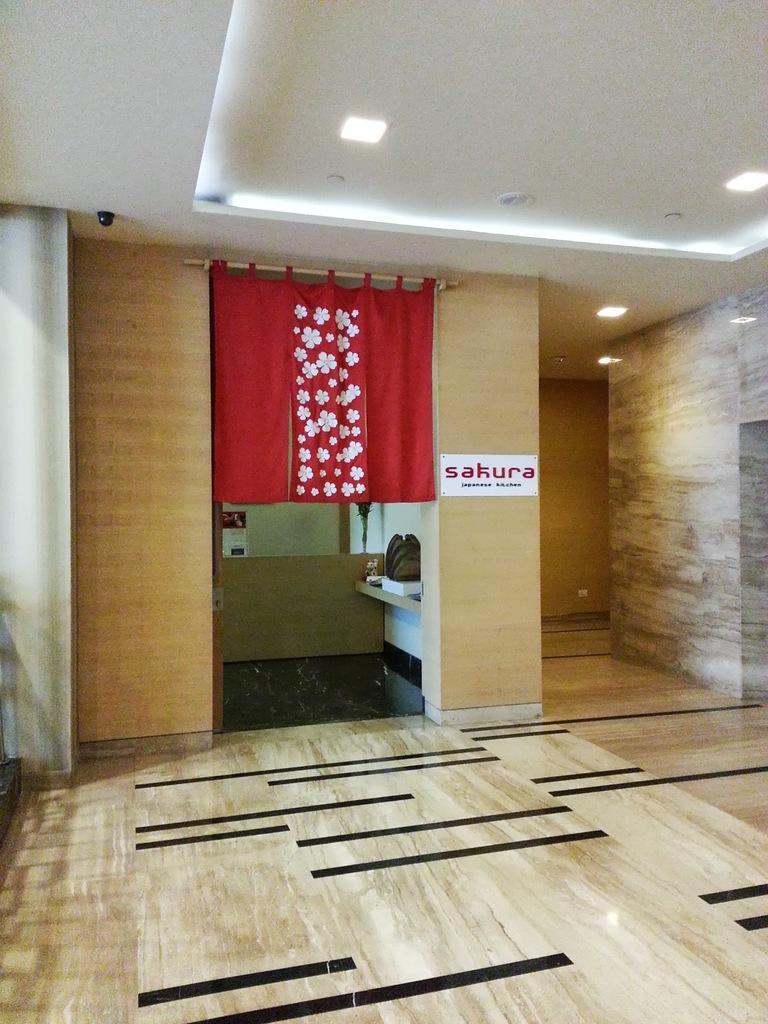Could you give a brief overview of what you see in this image? This is a picture of a room, in this image in the center there is a curtain and some poster on the wall. And in the background there are some objects, and on the right side of the image there is a wall and at the bottom there is floor. At the top there are some lights and ceiling, and on the left side of the image there is one camera and pillar. 